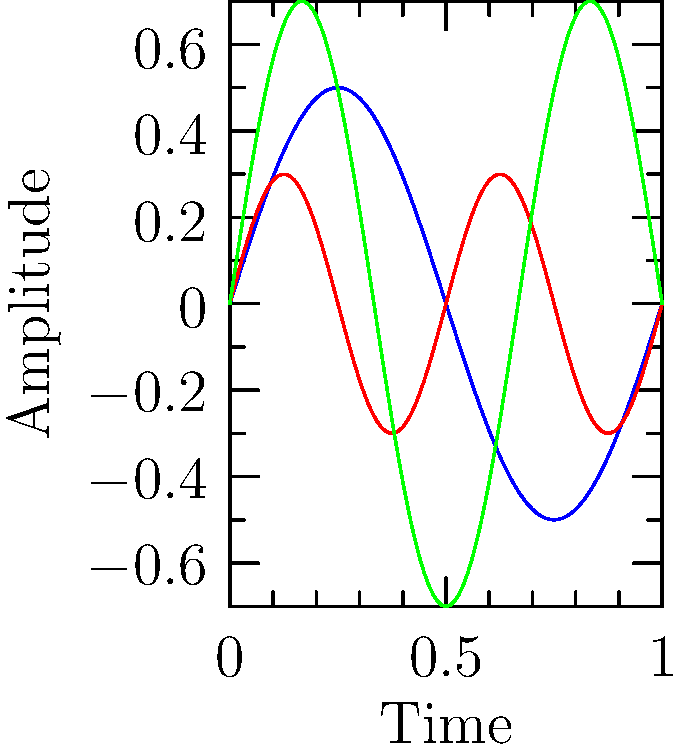Given the waveform visualizations of three different soundtrack compositions (A, B, and C), which one is most likely to have the highest therapeutic effectiveness for reducing anxiety in patients, based on its characteristics? To determine which waveform is most likely to have the highest therapeutic effectiveness for reducing anxiety, we need to consider the following steps:

1. Analyze the frequency of each waveform:
   - Waveform A: Medium frequency (2 complete cycles)
   - Waveform B: High frequency (4 complete cycles)
   - Waveform C: Medium-high frequency (3 complete cycles)

2. Examine the amplitude of each waveform:
   - Waveform A: Medium amplitude (0.5)
   - Waveform B: Low amplitude (0.3)
   - Waveform C: High amplitude (0.7)

3. Consider the impact of frequency and amplitude on anxiety reduction:
   - Lower frequencies are generally more calming and relaxing
   - Moderate amplitudes are often more soothing than extreme highs or lows

4. Evaluate the overall shape and consistency of each waveform:
   - Waveform A: Smooth, consistent, and moderate in both frequency and amplitude
   - Waveform B: Rapid oscillations may be overstimulating
   - Waveform C: Higher amplitude may be too intense for anxiety reduction

5. Apply knowledge of music therapy principles:
   - Gentle, consistent rhythms are typically more effective for anxiety reduction
   - Overly complex or intense compositions may increase arousal and anxiety

Based on these considerations, Waveform A is most likely to have the highest therapeutic effectiveness for reducing anxiety. Its moderate frequency and amplitude, combined with a smooth and consistent pattern, align best with principles of using music for anxiety reduction in music therapy.
Answer: Waveform A 